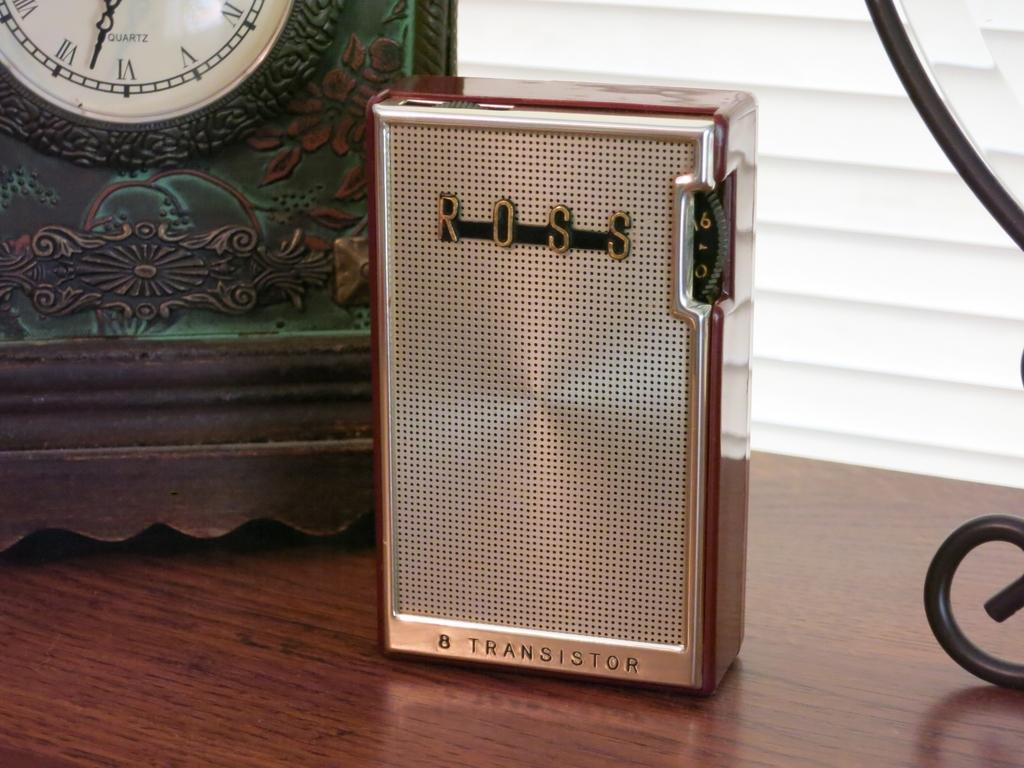<image>
Relay a brief, clear account of the picture shown. A silver "ROSS" transistor is on a table. 